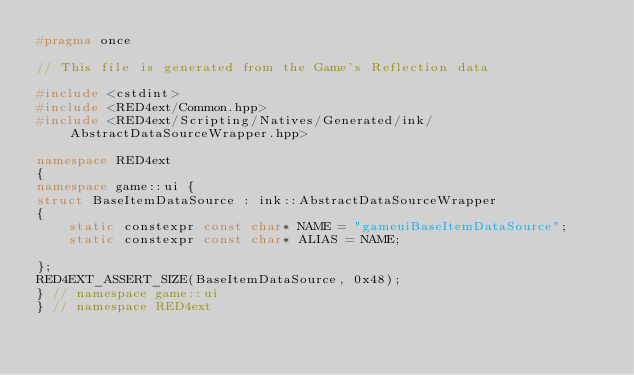Convert code to text. <code><loc_0><loc_0><loc_500><loc_500><_C++_>#pragma once

// This file is generated from the Game's Reflection data

#include <cstdint>
#include <RED4ext/Common.hpp>
#include <RED4ext/Scripting/Natives/Generated/ink/AbstractDataSourceWrapper.hpp>

namespace RED4ext
{
namespace game::ui { 
struct BaseItemDataSource : ink::AbstractDataSourceWrapper
{
    static constexpr const char* NAME = "gameuiBaseItemDataSource";
    static constexpr const char* ALIAS = NAME;

};
RED4EXT_ASSERT_SIZE(BaseItemDataSource, 0x48);
} // namespace game::ui
} // namespace RED4ext
</code> 